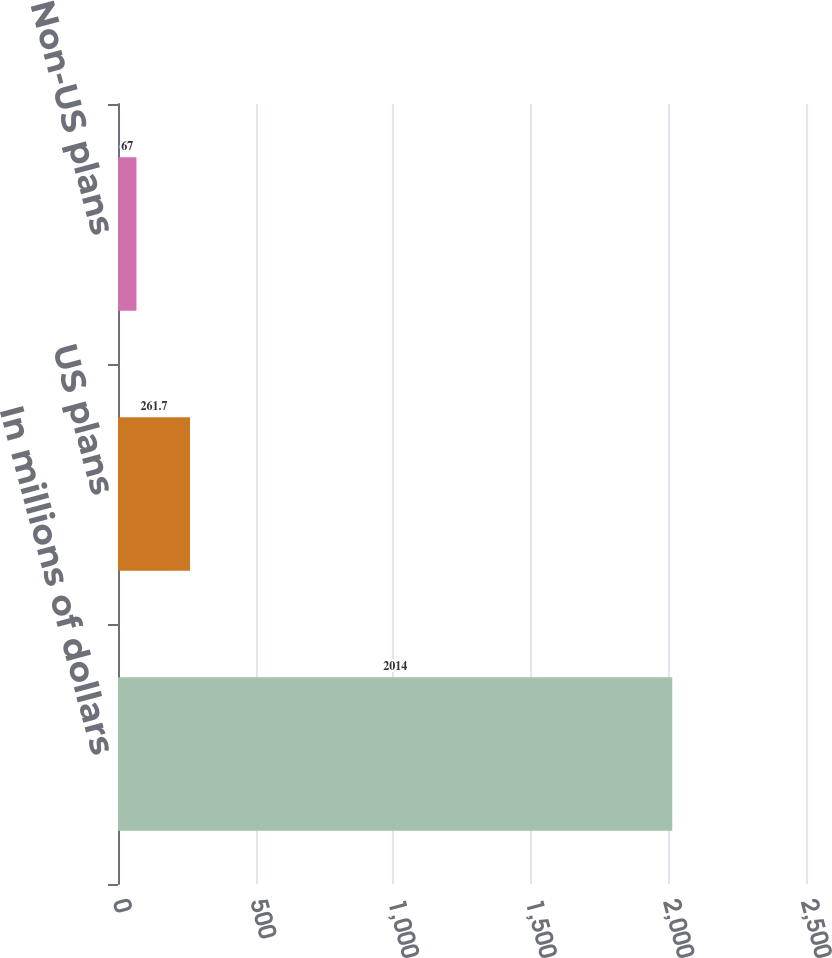Convert chart to OTSL. <chart><loc_0><loc_0><loc_500><loc_500><bar_chart><fcel>In millions of dollars<fcel>US plans<fcel>Non-US plans<nl><fcel>2014<fcel>261.7<fcel>67<nl></chart> 